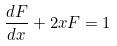<formula> <loc_0><loc_0><loc_500><loc_500>\frac { d F } { d x } + 2 x F = 1</formula> 